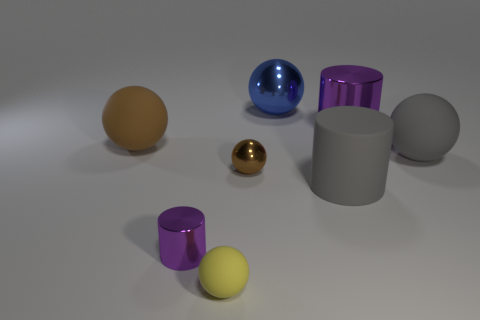What number of big brown metal cylinders are there?
Offer a terse response. 0. Is the material of the ball that is on the left side of the small yellow matte sphere the same as the gray sphere?
Offer a terse response. Yes. Are there any cylinders that have the same size as the blue thing?
Ensure brevity in your answer.  Yes. Is the shape of the tiny purple metallic thing the same as the big gray matte thing that is behind the rubber cylinder?
Provide a short and direct response. No. Is there a tiny thing in front of the brown object right of the metallic cylinder that is on the left side of the large blue thing?
Give a very brief answer. Yes. What is the size of the brown metallic object?
Provide a short and direct response. Small. What number of other objects are the same color as the tiny metal ball?
Give a very brief answer. 1. Does the thing behind the large metal cylinder have the same shape as the tiny purple shiny object?
Provide a short and direct response. No. What color is the other small thing that is the same shape as the small brown thing?
Give a very brief answer. Yellow. Is there anything else that is the same material as the large blue object?
Ensure brevity in your answer.  Yes. 